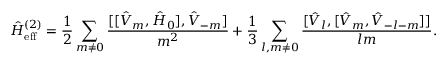Convert formula to latex. <formula><loc_0><loc_0><loc_500><loc_500>\hat { H } _ { e f f } ^ { ( 2 ) } = \frac { 1 } { 2 } \sum _ { m \neq 0 } \frac { [ [ \hat { V } _ { m } , \hat { H } _ { 0 } ] , \hat { V } _ { - m } ] } { m ^ { 2 } } + \frac { 1 } { 3 } \sum _ { l , m \neq 0 } \frac { [ \hat { V } _ { l } , [ \hat { V } _ { m } , \hat { V } _ { - l - m } ] ] } { l m } .</formula> 